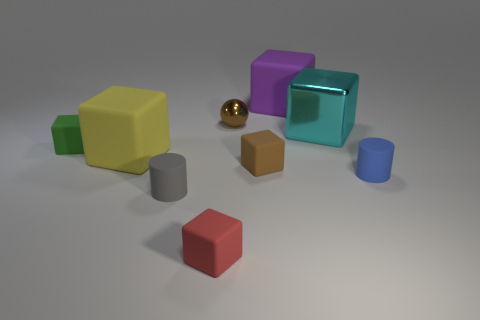How many large things are matte cubes or blue matte cylinders?
Keep it short and to the point. 2. There is a cube that is the same color as the small metallic sphere; what material is it?
Offer a very short reply. Rubber. Is the number of big purple balls less than the number of big yellow matte objects?
Ensure brevity in your answer.  Yes. There is a metal object to the left of the metallic cube; is its size the same as the brown thing in front of the cyan shiny thing?
Your answer should be very brief. Yes. How many blue objects are either small objects or metal cylinders?
Offer a terse response. 1. There is a object that is the same color as the shiny ball; what size is it?
Offer a terse response. Small. Is the number of small blocks greater than the number of small blue cylinders?
Your answer should be compact. Yes. Do the big metal cube and the tiny metallic sphere have the same color?
Your answer should be very brief. No. What number of things are tiny green shiny cylinders or blocks on the right side of the small gray matte object?
Offer a very short reply. 4. What number of other objects are the same shape as the big purple matte thing?
Make the answer very short. 5. 